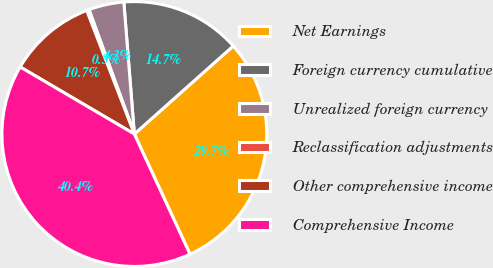Convert chart to OTSL. <chart><loc_0><loc_0><loc_500><loc_500><pie_chart><fcel>Net Earnings<fcel>Foreign currency cumulative<fcel>Unrealized foreign currency<fcel>Reclassification adjustments<fcel>Other comprehensive income<fcel>Comprehensive Income<nl><fcel>29.67%<fcel>14.69%<fcel>4.3%<fcel>0.29%<fcel>10.69%<fcel>40.36%<nl></chart> 